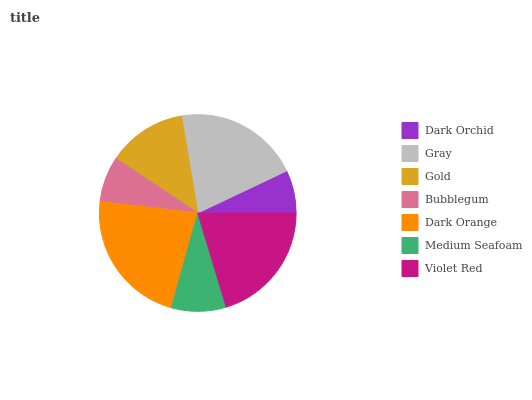Is Dark Orchid the minimum?
Answer yes or no. Yes. Is Dark Orange the maximum?
Answer yes or no. Yes. Is Gray the minimum?
Answer yes or no. No. Is Gray the maximum?
Answer yes or no. No. Is Gray greater than Dark Orchid?
Answer yes or no. Yes. Is Dark Orchid less than Gray?
Answer yes or no. Yes. Is Dark Orchid greater than Gray?
Answer yes or no. No. Is Gray less than Dark Orchid?
Answer yes or no. No. Is Gold the high median?
Answer yes or no. Yes. Is Gold the low median?
Answer yes or no. Yes. Is Medium Seafoam the high median?
Answer yes or no. No. Is Medium Seafoam the low median?
Answer yes or no. No. 